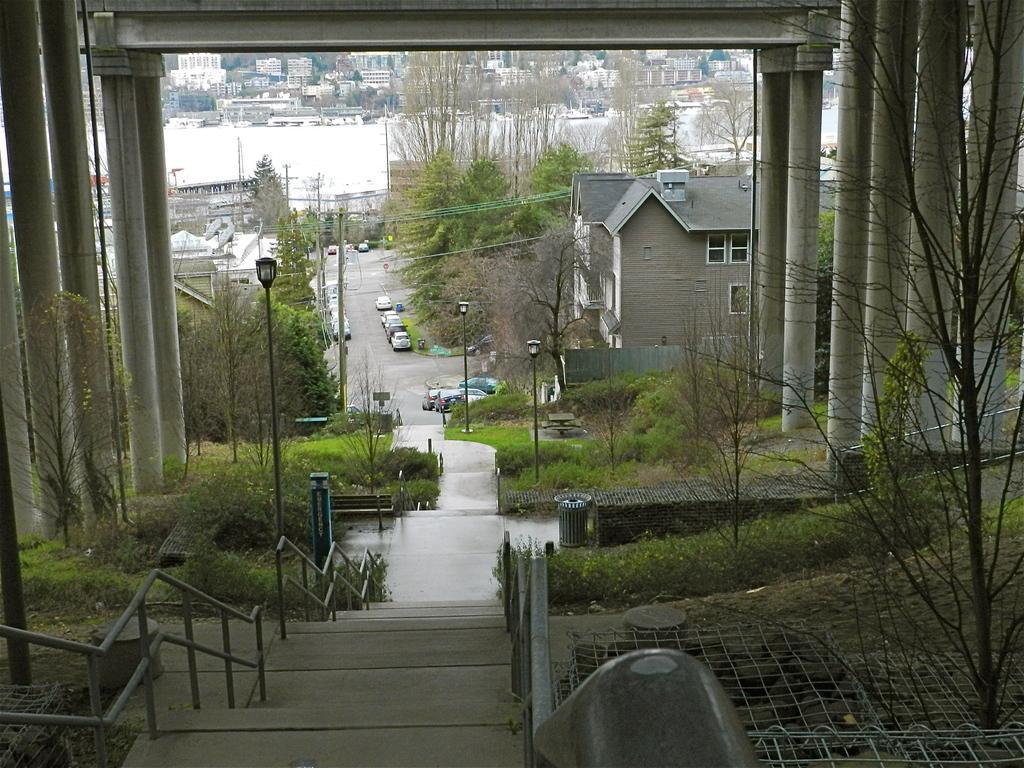In one or two sentences, can you explain what this image depicts? In this image I can see the stairs and the railing. To the right I can see the net. On both sides I can see the many trees and pillars. In the background I can see the poles and vehicles on the road. On both sides of the road I can see the buildings and trees. I can also see the water, many buildings in the back. 